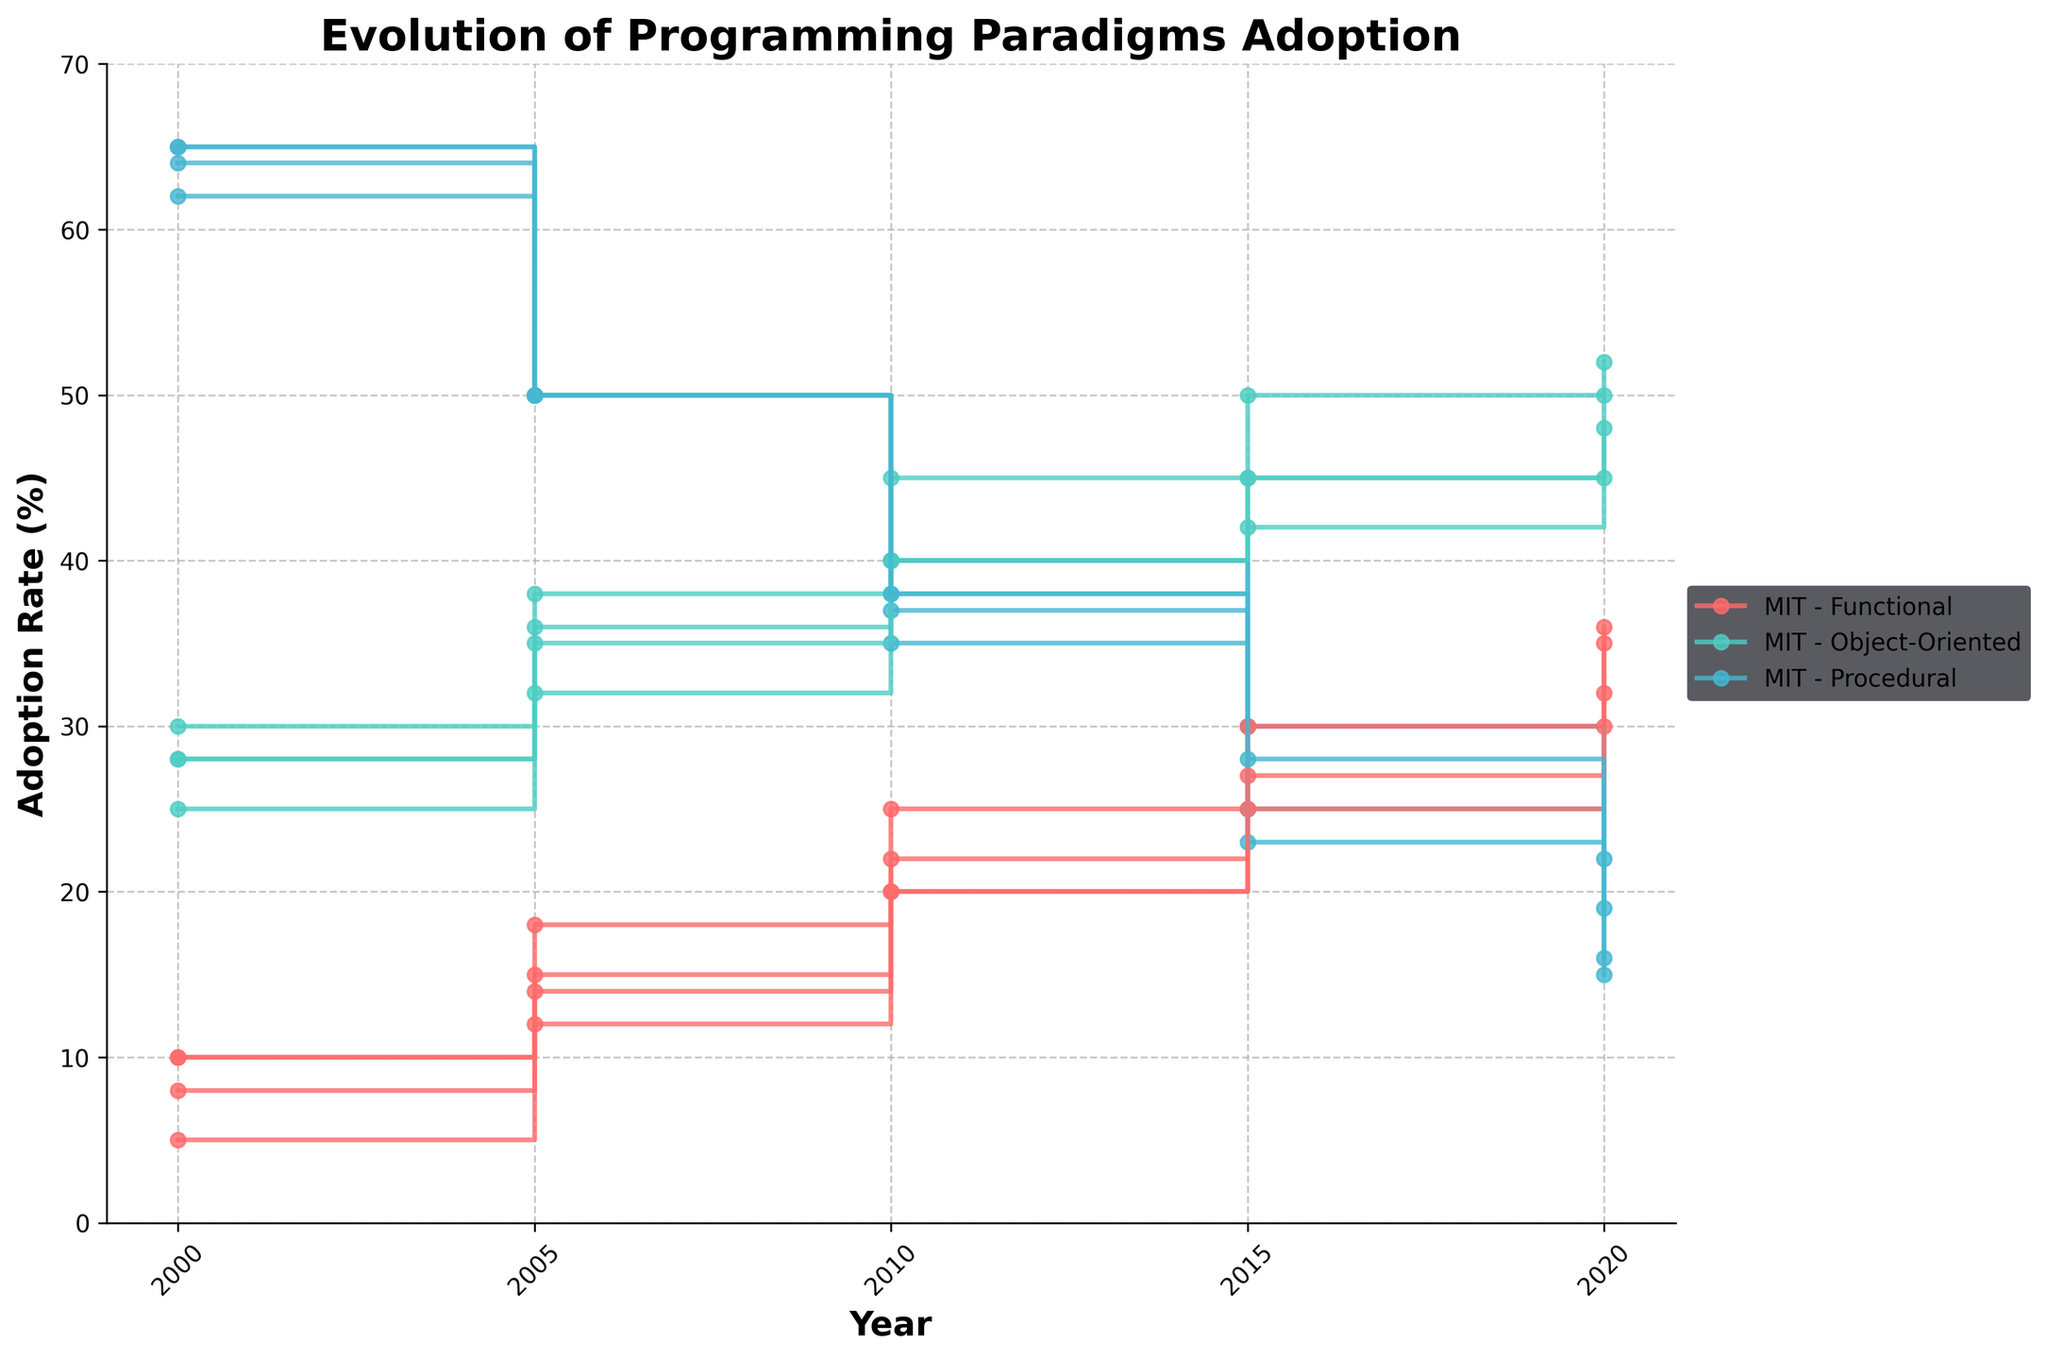What is the title of the figure? The title is located at the top of the figure in bold text, indicating the main subject of the plot.
Answer: Evolution of Programming Paradigms Adoption How many institutions are represented in the figure? The legend to the right of the plot lists each institution once along with the paradigms. By counting the unique institutions, we identify four: MIT, Stanford, Carnegie Mellon, and UC Berkeley.
Answer: Four Which programming paradigm had the highest adoption rate in MIT in the year 2000? By examining the stair plot, look for the markers corresponding to MIT in 2000 and identify which line (paradigm color) is at the highest point on the vertical axis (adoption rate).
Answer: Procedural By what percentage did the adoption of Functional programming at UC Berkeley increase between 2000 and 2020? First, note the adoption rates of Functional programming for UC Berkeley in 2000 (10%) and 2020 (36%). Subtract the former from the latter to find the increase: 36% - 10% = 26%.
Answer: 26% Which institution had the most consistent (i.e., least variable) adoption rates of Object-Oriented programming from 2000 to 2020? To find the most consistent institution, examine the step plot lines for Object-Oriented across the institutions. Look for the one with the least variations or smallest changes in vertical positions across years. Carnegie Mellon shows the smallest variations.
Answer: Carnegie Mellon What was the trend in adoption rates of Procedural programming at Stanford from 2000 to 2020? Observe the stair steps in the Procedural programming line for Stanford across the years 2000 to 2020. The line generally declines, indicating a decreasing trend in adoption rates.
Answer: Decreasing Compare the adoption rates of Object-Oriented programming at MIT versus Stanford in 2020. Which institution had a higher rate, and by how much? Find the adoption rates for Object-Oriented programming in 2020 for both MIT (50%) and Stanford (48%). MIT had the higher rate. The difference is 50% - 48% = 2%.
Answer: MIT by 2% What is the range of adoption rates for Functional programming at Carnegie Mellon from 2000 to 2020? Note the minimum and maximum adoption rates for Functional programming at Carnegie Mellon over the years: minimum (5% in 2000) and maximum (32% in 2020). The range is 32% - 5% = 27%.
Answer: 27% Which programming paradigm saw an increase in adoption rate at all institutions from 2000 to 2020? Review the step plots for all three programming paradigms across the four institutions from 2000 to 2020. Functional programming shows a consistent increase at all institutions over this period.
Answer: Functional 